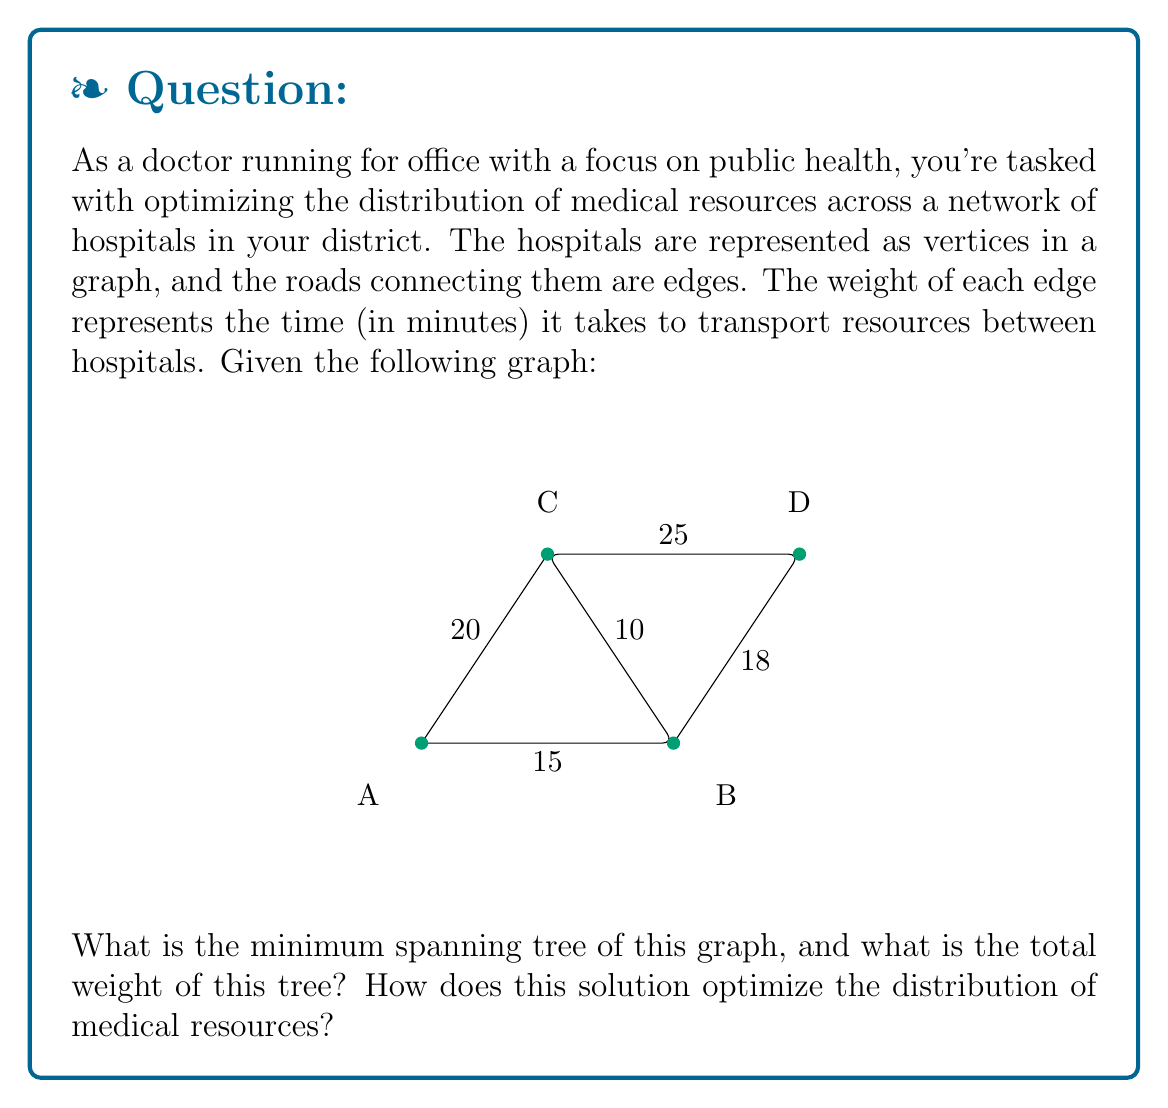Teach me how to tackle this problem. To solve this problem, we'll use Kruskal's algorithm to find the minimum spanning tree (MST) of the given graph. This algorithm is ideal for optimizing the distribution of medical resources as it minimizes the total time required to connect all hospitals while ensuring that resources can be transported between any two hospitals.

Steps of Kruskal's algorithm:

1. Sort all edges by weight (time) in ascending order:
   BC (10), AB (15), BD (18), AC (20), CD (25)

2. Start with an empty set of edges and add edges one by one, ensuring no cycles are formed:

   a. Add BC (10)
   b. Add AB (15)
   c. Add BD (18)

At this point, we have connected all vertices (hospitals) without forming any cycles. We stop here as adding any more edges would create cycles.

The resulting minimum spanning tree is:

[asy]
unitsize(1cm);
pair A = (0,0), B = (4,0), C = (2,3), D = (6,3);
dot("A", A, SW);
dot("B", B, SE);
dot("C", C, N);
dot("D", D, N);
draw(A--B--C--D);
label("15", (A+B)/2, S);
label("10", (B+C)/2, NE);
label("18", (B+D)/2, SE);
[/asy]

The total weight of the MST is the sum of the weights of the selected edges:
$$10 + 15 + 18 = 43$$

This solution optimizes the distribution of medical resources by:

1. Minimizing the total time required to connect all hospitals (43 minutes).
2. Ensuring that resources can be transported between any two hospitals through the most efficient routes.
3. Eliminating redundant connections, which can help reduce maintenance costs and simplify logistics.

By using this MST, you can establish an efficient network for resource sharing, allowing for quick and effective distribution of medical supplies, equipment, and personnel across the hospital network in your district.
Answer: The minimum spanning tree consists of edges BC, AB, and BD, with a total weight of 43 minutes. 